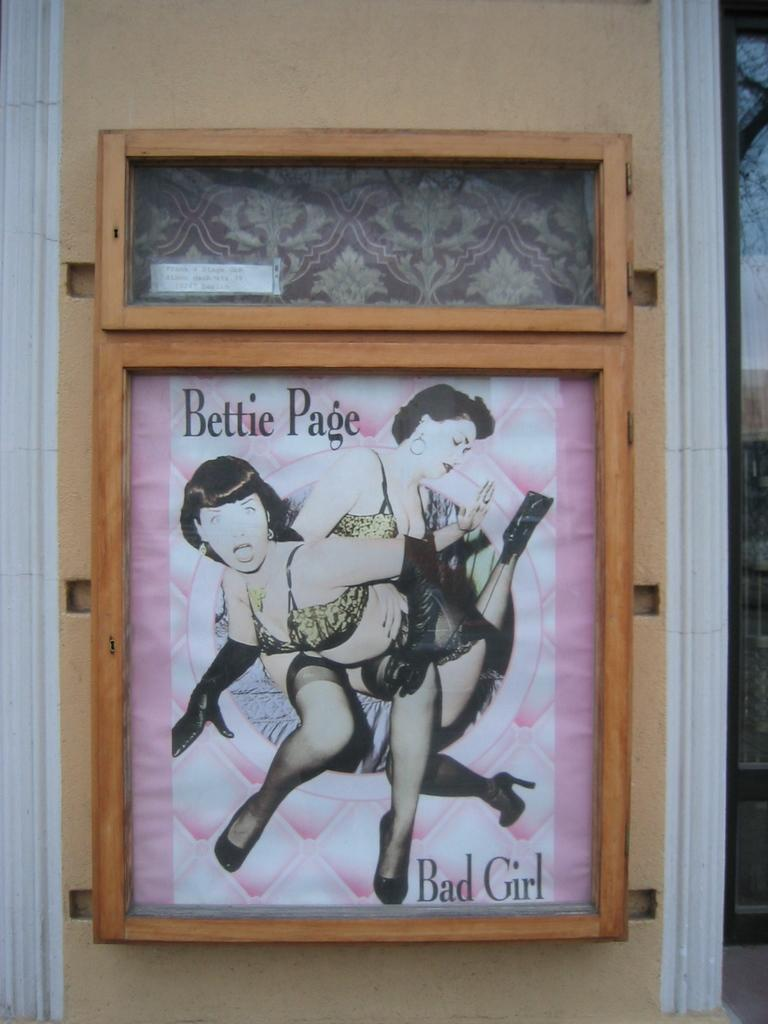<image>
Relay a brief, clear account of the picture shown. a framed picture of two women that are called bettie page. 